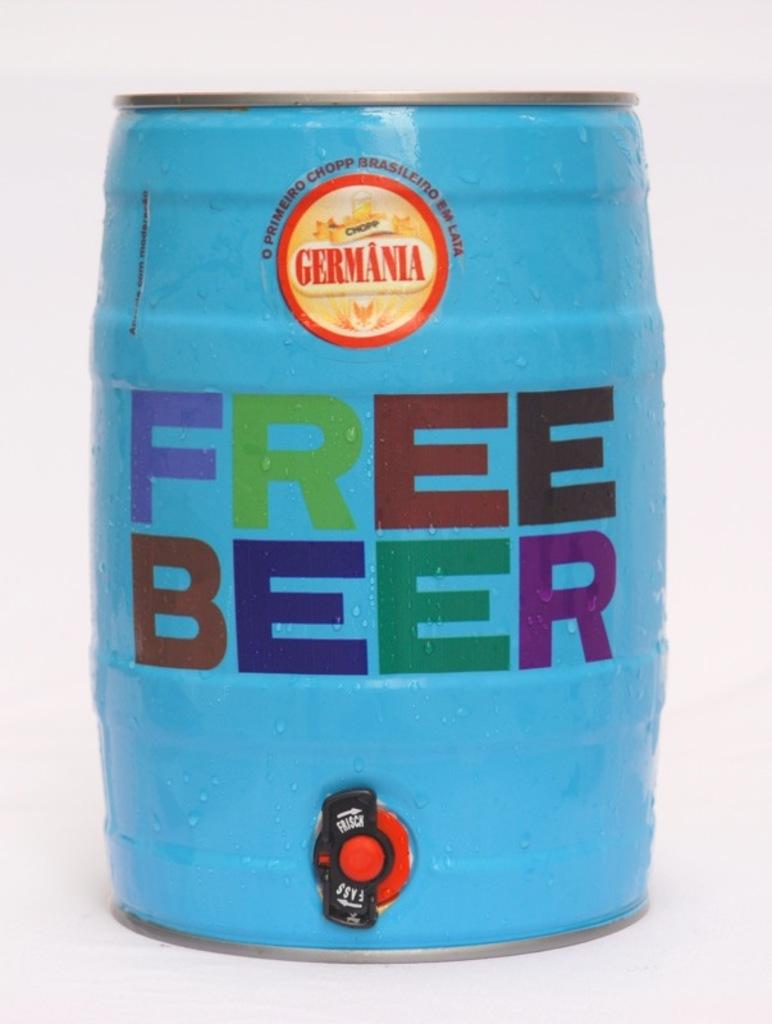What does it say in big letters on the keg?
Your response must be concise. Free beer. What does the logo say?
Offer a terse response. Free beer. 